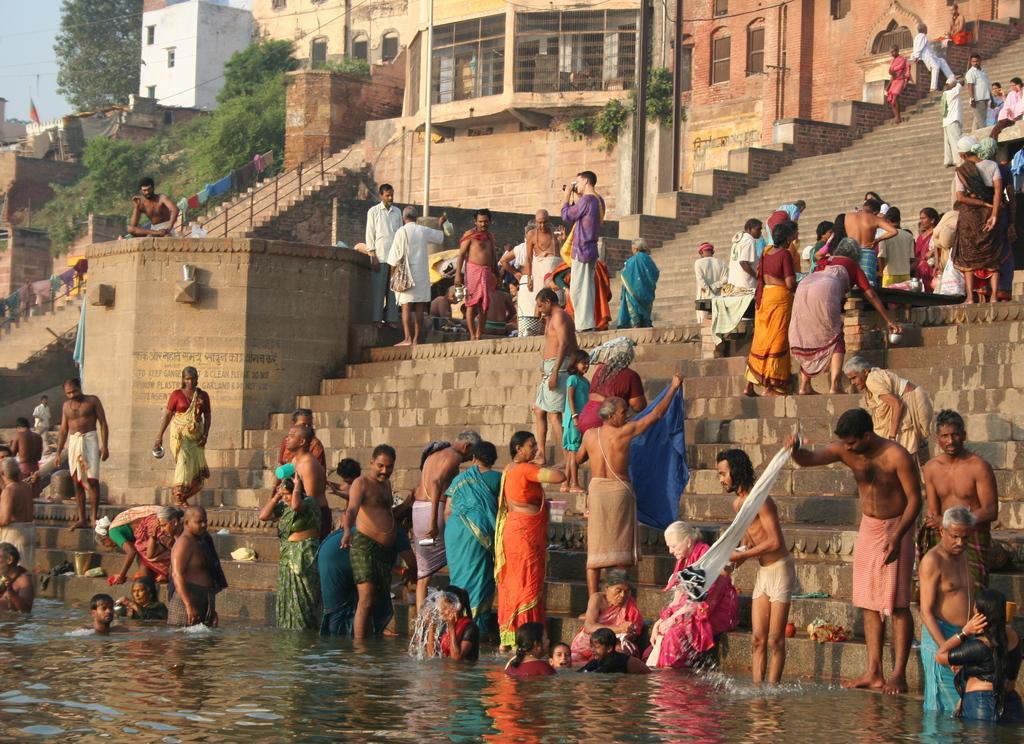In one or two sentences, can you explain what this image depicts? In this image we can see a few people standing on the stairs and few people in the water. In the background, we can see the buildings and stairs. And there are trees, clothes, wall with text and sky. 